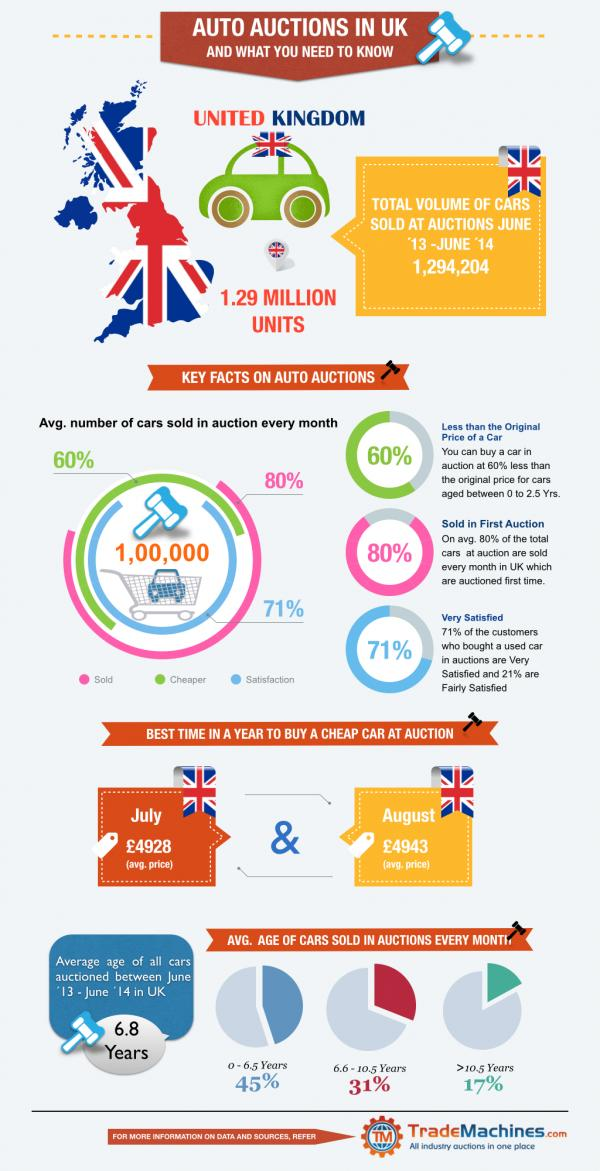Draw attention to some important aspects in this diagram. The cars that are least preferred are those that are older than 10.5 years. 